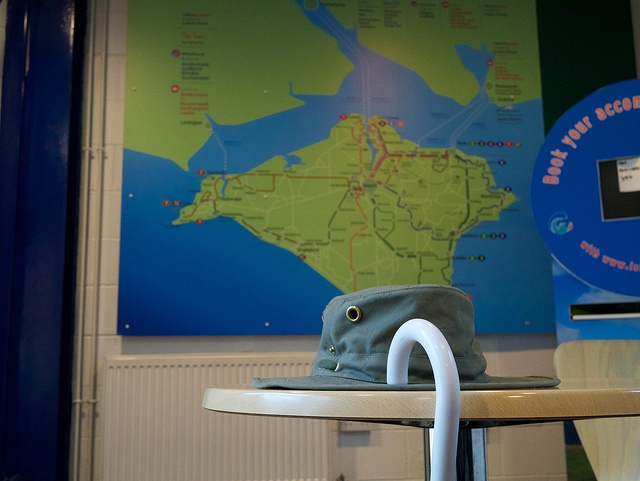Describe the objects in this image and their specific colors. I can see dining table in black, lightgray, darkgray, and olive tones, chair in black, gray, and darkgray tones, and umbrella in black, lightblue, darkgray, and gray tones in this image. 